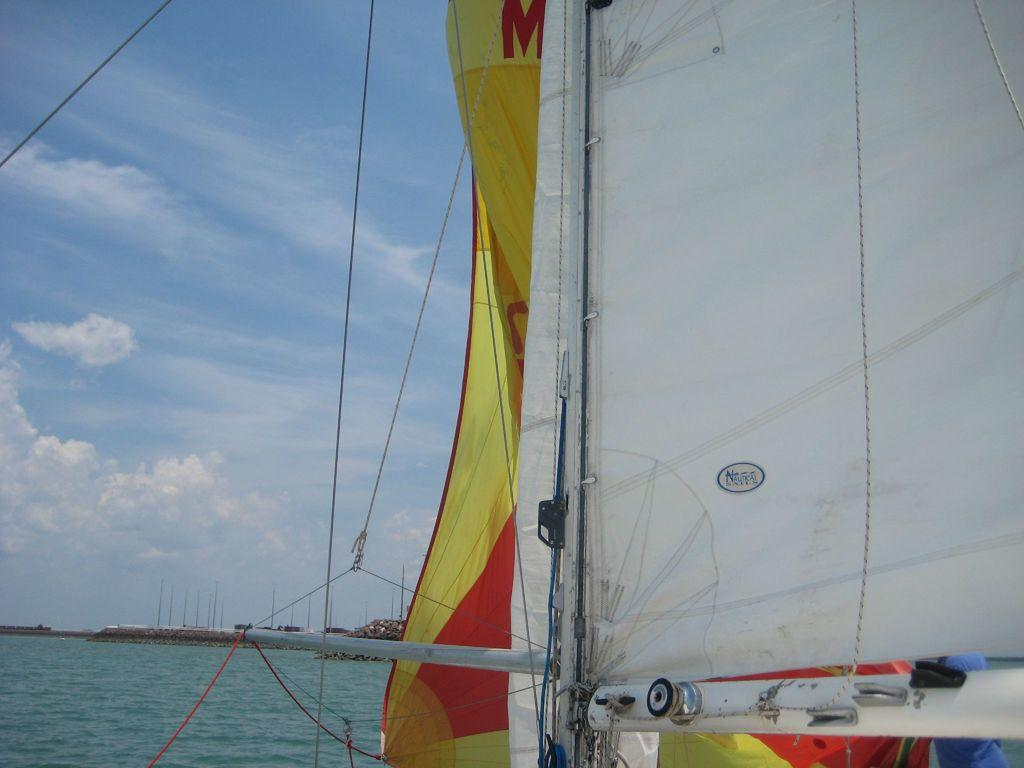What objects can be seen in the front of the image? There are clothes, poles, and ropes in the front of the image. What is visible in the background of the image? Water, clouds, and the sky are visible in the background of the image. What type of wood can be seen in the image? There is no wood present in the image. Is there a baseball game happening in the image? There is no indication of a baseball game or any sports activity in the image. 